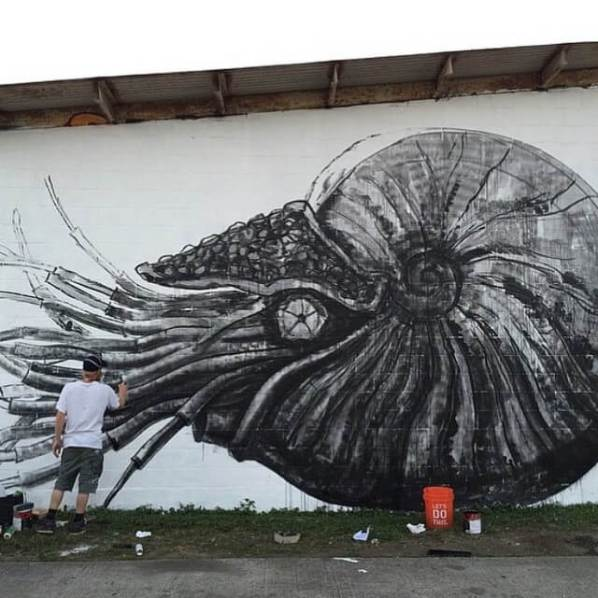Imagine this mural comes alive at night. What kind of scene would unfold? As the night falls, the mural begins to shimmer with an ethereal glow. The cephalopod depicted in the artwork starts to move, its tentacles swaying gently as if caught in an invisible current. You can hear the soft sound of the ocean waves, a contrast to the hustle of the day. The detailed textures of the creature’s shell and tentacles reflect a bioluminescent light, creating a mesmerizing display. The mural’s transformation brings a sense of mystique to the surroundings as the cephalopod embarks on a slow, graceful journey along the wall, exploring its painted habitat. The plants at the base seem to extend upward, swaying along to the rhythm of the creature’s movements. It's a magical scene, where art and reality blend seamlessly, captivating anyone who stumbles upon it. If this mural were part of an animated movie, what would be its storyline? In an animated movie, this mural could serve as the gateway to an underwater adventure. The storyline might revolve around a young artist who, upon completing the mural, discovers that it holds a magical secret: it can come to life and transport people to an enchanted sea world. One evening, the artist touches the mural and is pulled into a breathtaking, underwater realm. In this world, the cephalopod becomes a wise guardian who guides the artist through a series of challenges to restore balance to the underwater kingdom. Along the way, the artist learns important lessons about courage, creativity, and the interconnectedness of all living things. The mural in their world remains a living testament to their adventure, reminding others of the beauty and mystery that lies beneath the surface. 